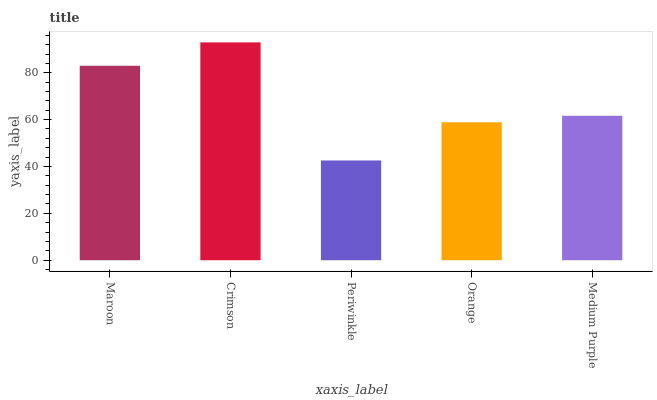Is Periwinkle the minimum?
Answer yes or no. Yes. Is Crimson the maximum?
Answer yes or no. Yes. Is Crimson the minimum?
Answer yes or no. No. Is Periwinkle the maximum?
Answer yes or no. No. Is Crimson greater than Periwinkle?
Answer yes or no. Yes. Is Periwinkle less than Crimson?
Answer yes or no. Yes. Is Periwinkle greater than Crimson?
Answer yes or no. No. Is Crimson less than Periwinkle?
Answer yes or no. No. Is Medium Purple the high median?
Answer yes or no. Yes. Is Medium Purple the low median?
Answer yes or no. Yes. Is Orange the high median?
Answer yes or no. No. Is Maroon the low median?
Answer yes or no. No. 